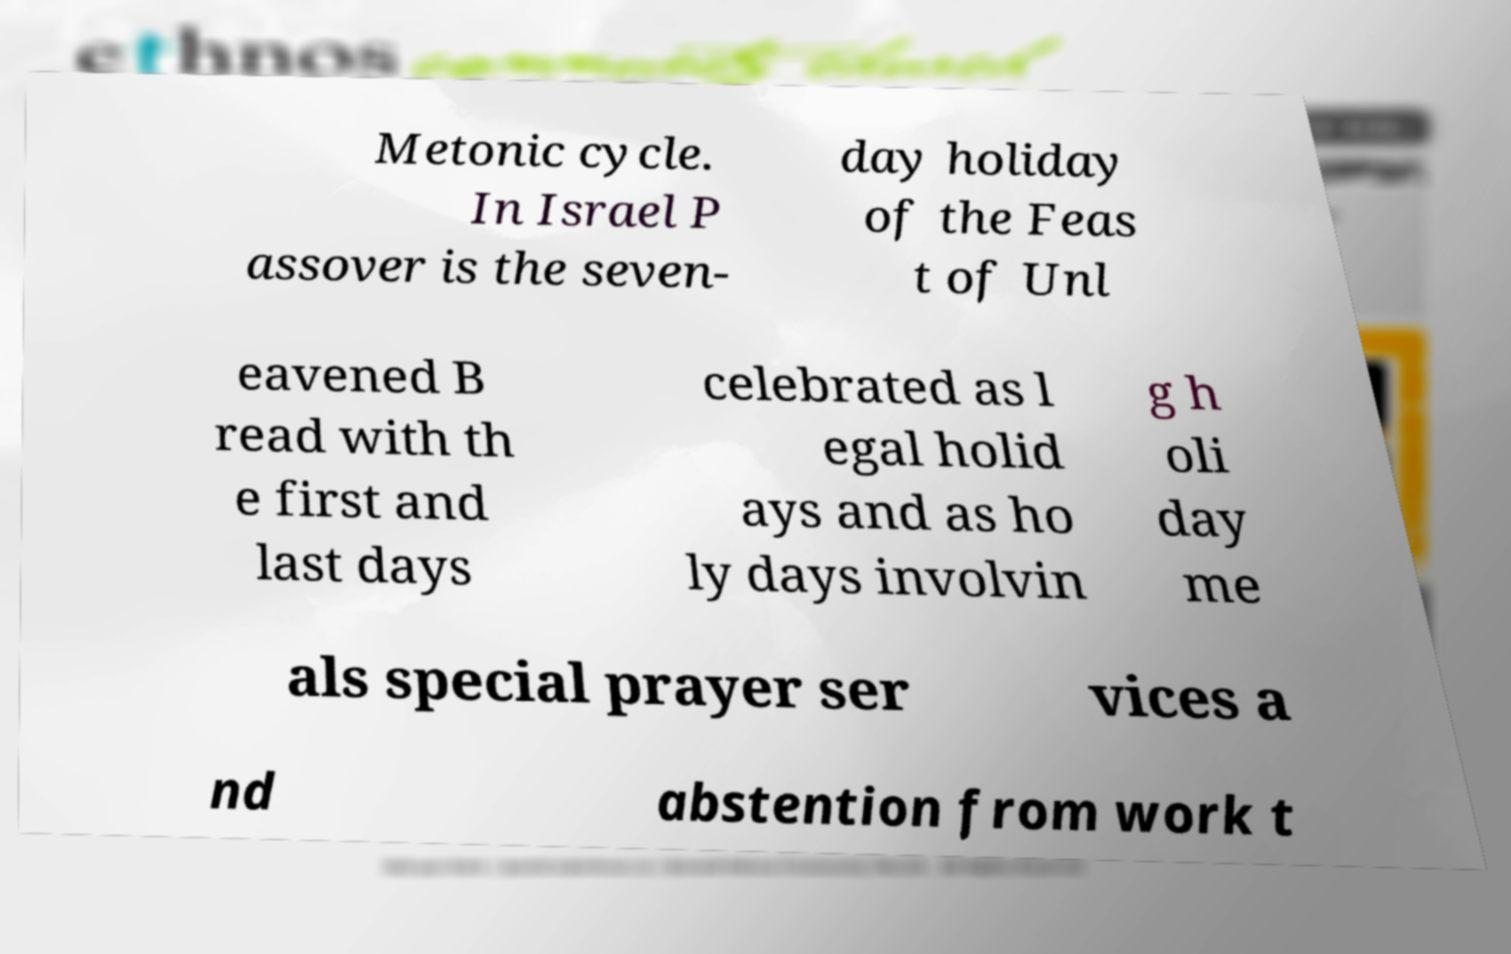Could you assist in decoding the text presented in this image and type it out clearly? Metonic cycle. In Israel P assover is the seven- day holiday of the Feas t of Unl eavened B read with th e first and last days celebrated as l egal holid ays and as ho ly days involvin g h oli day me als special prayer ser vices a nd abstention from work t 